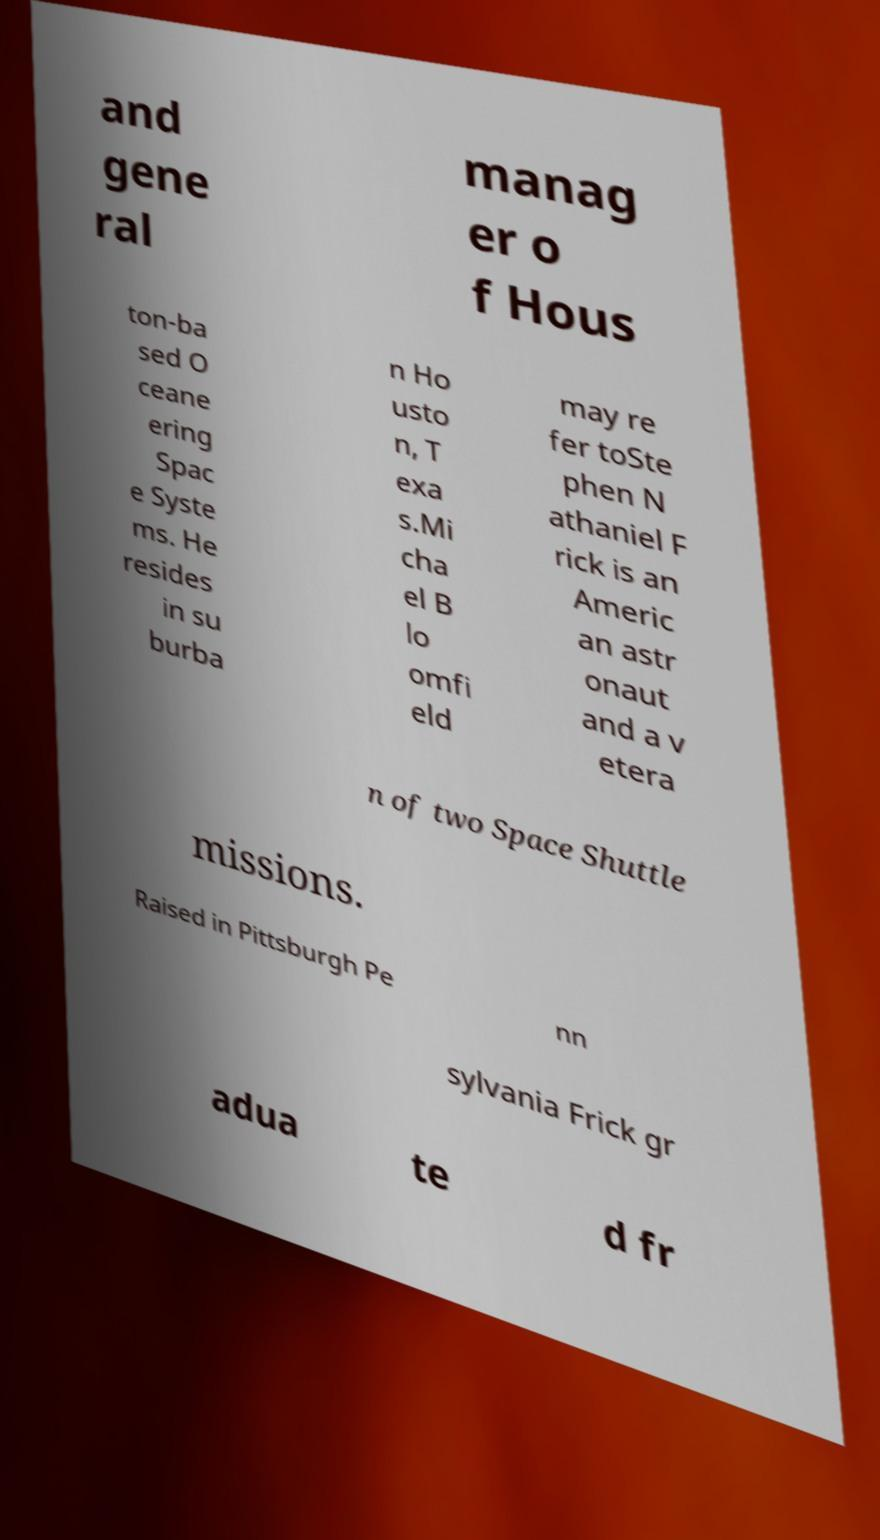I need the written content from this picture converted into text. Can you do that? and gene ral manag er o f Hous ton-ba sed O ceane ering Spac e Syste ms. He resides in su burba n Ho usto n, T exa s.Mi cha el B lo omfi eld may re fer toSte phen N athaniel F rick is an Americ an astr onaut and a v etera n of two Space Shuttle missions. Raised in Pittsburgh Pe nn sylvania Frick gr adua te d fr 